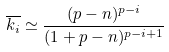Convert formula to latex. <formula><loc_0><loc_0><loc_500><loc_500>\overline { k _ { i } } \simeq \frac { ( p - n ) ^ { p - i } } { ( 1 + p - n ) ^ { p - i + 1 } }</formula> 